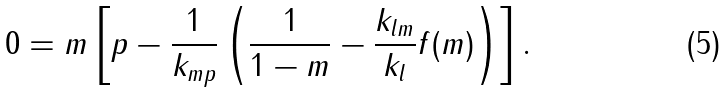Convert formula to latex. <formula><loc_0><loc_0><loc_500><loc_500>0 = m \left [ p - \frac { 1 } { k _ { m p } } \left ( \frac { 1 } { 1 - m } - \frac { k _ { l m } } { k _ { l } } f ( m ) \right ) \right ] .</formula> 